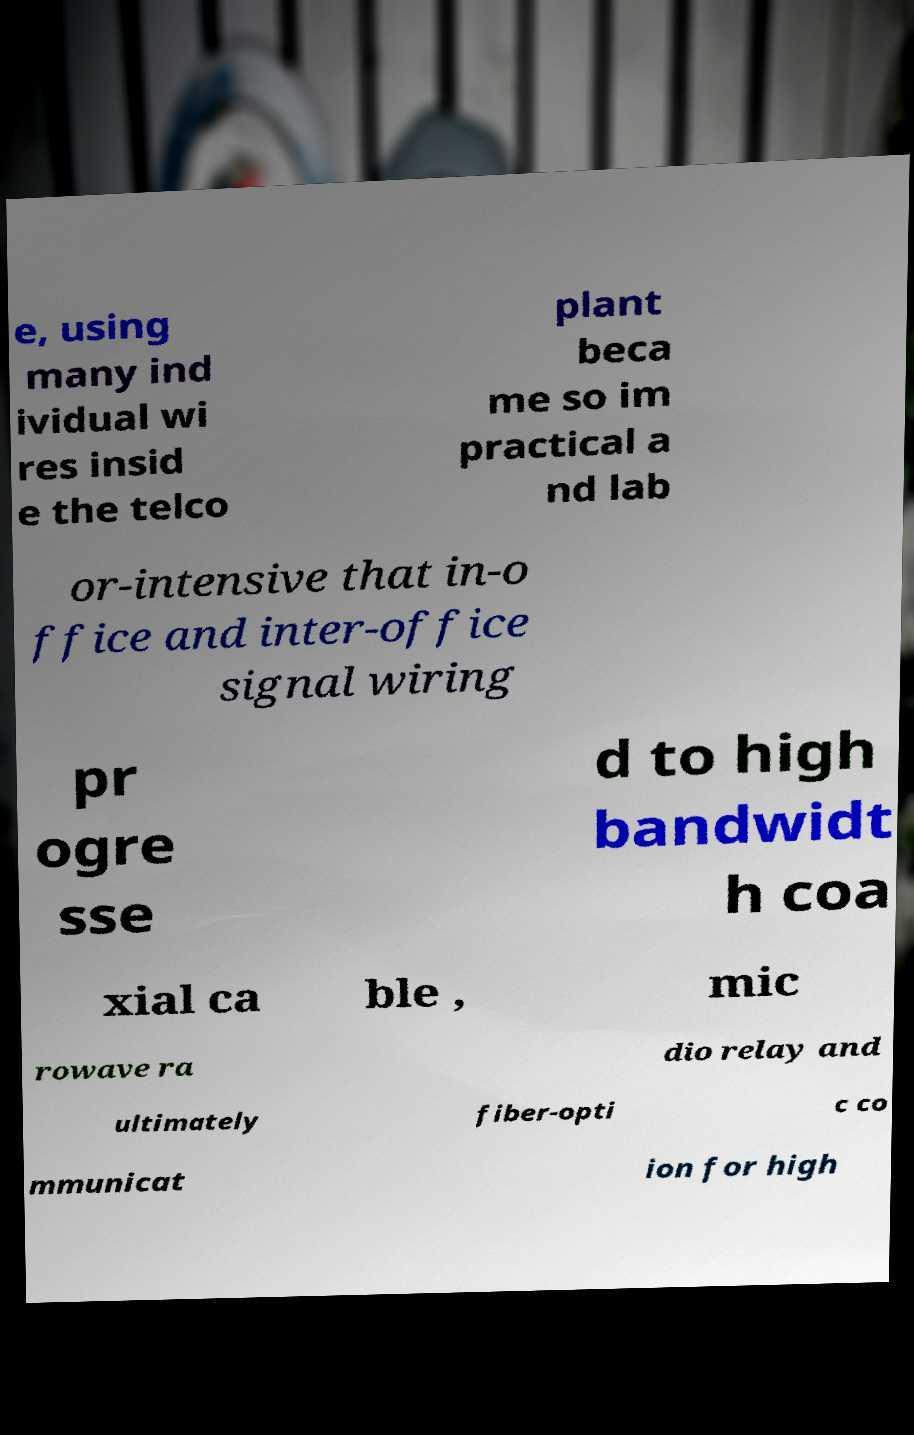Can you read and provide the text displayed in the image?This photo seems to have some interesting text. Can you extract and type it out for me? e, using many ind ividual wi res insid e the telco plant beca me so im practical a nd lab or-intensive that in-o ffice and inter-office signal wiring pr ogre sse d to high bandwidt h coa xial ca ble , mic rowave ra dio relay and ultimately fiber-opti c co mmunicat ion for high 